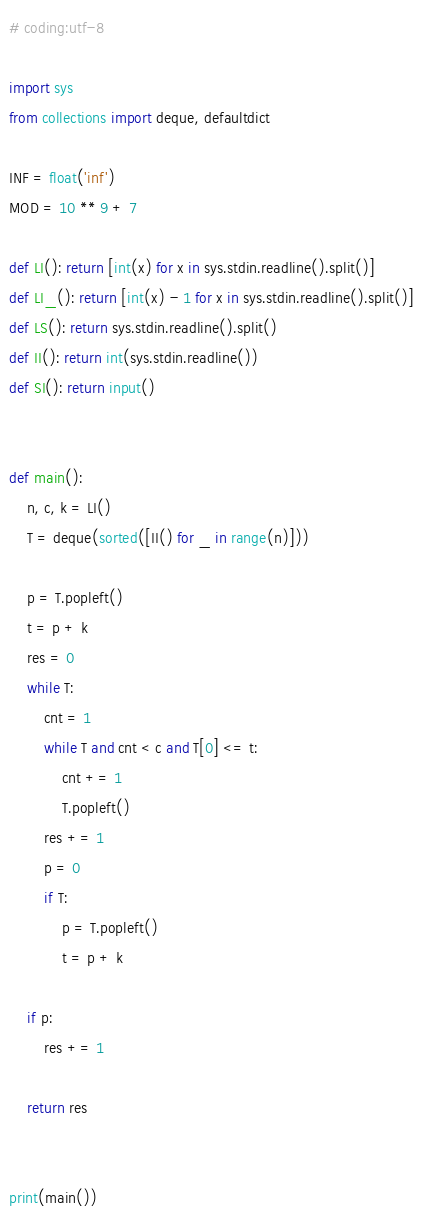<code> <loc_0><loc_0><loc_500><loc_500><_Python_># coding:utf-8

import sys
from collections import deque, defaultdict

INF = float('inf')
MOD = 10 ** 9 + 7

def LI(): return [int(x) for x in sys.stdin.readline().split()]
def LI_(): return [int(x) - 1 for x in sys.stdin.readline().split()]
def LS(): return sys.stdin.readline().split()
def II(): return int(sys.stdin.readline())
def SI(): return input()


def main():
    n, c, k = LI()
    T = deque(sorted([II() for _ in range(n)]))

    p = T.popleft()
    t = p + k
    res = 0
    while T:
        cnt = 1
        while T and cnt < c and T[0] <= t:
            cnt += 1
            T.popleft()
        res += 1
        p = 0
        if T:
            p = T.popleft()
            t = p + k

    if p:
        res += 1

    return res


print(main())
</code> 